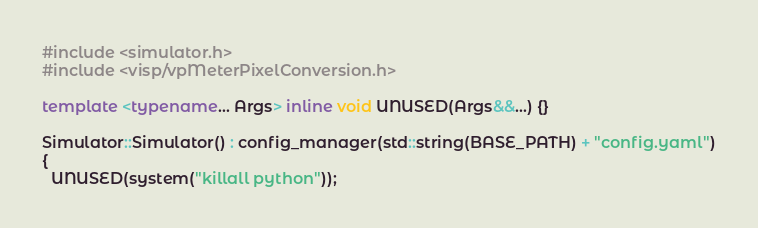Convert code to text. <code><loc_0><loc_0><loc_500><loc_500><_C++_>#include <simulator.h>
#include <visp/vpMeterPixelConversion.h>

template <typename... Args> inline void UNUSED(Args&&...) {}

Simulator::Simulator() : config_manager(std::string(BASE_PATH) + "config.yaml")
{
  UNUSED(system("killall python"));
</code> 